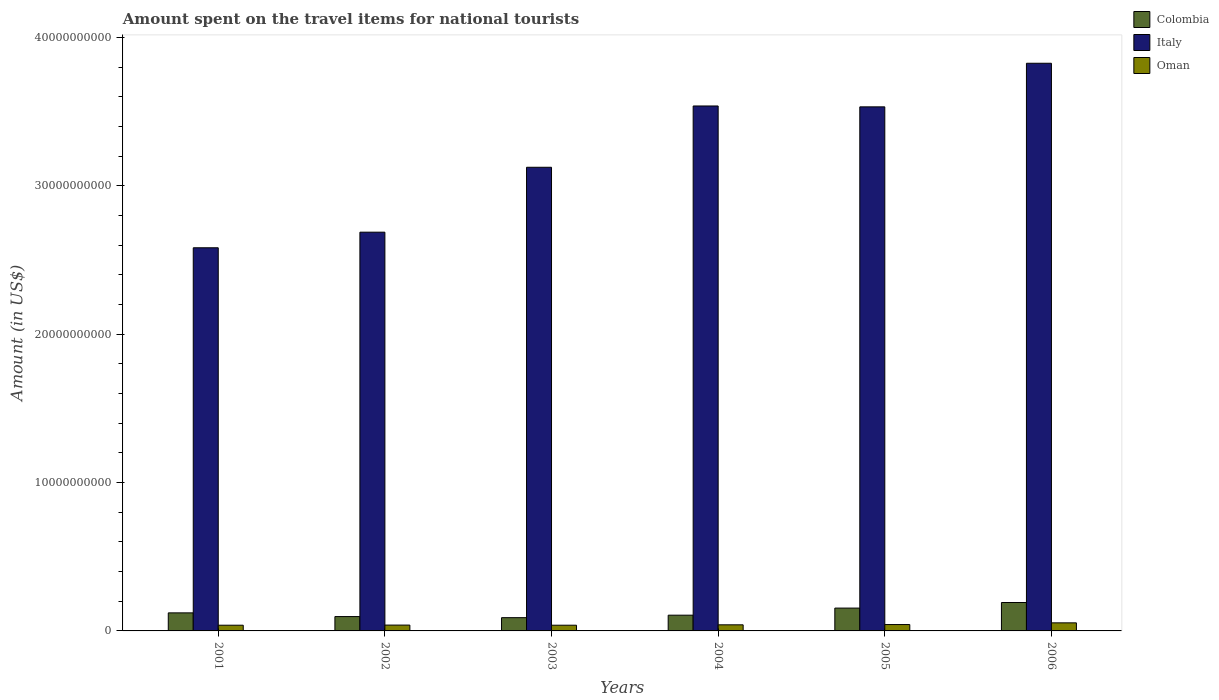Are the number of bars per tick equal to the number of legend labels?
Provide a succinct answer. Yes. How many bars are there on the 5th tick from the right?
Ensure brevity in your answer.  3. In how many cases, is the number of bars for a given year not equal to the number of legend labels?
Offer a very short reply. 0. What is the amount spent on the travel items for national tourists in Italy in 2002?
Provide a short and direct response. 2.69e+1. Across all years, what is the maximum amount spent on the travel items for national tourists in Italy?
Ensure brevity in your answer.  3.83e+1. Across all years, what is the minimum amount spent on the travel items for national tourists in Oman?
Your response must be concise. 3.85e+08. In which year was the amount spent on the travel items for national tourists in Colombia minimum?
Ensure brevity in your answer.  2003. What is the total amount spent on the travel items for national tourists in Oman in the graph?
Give a very brief answer. 2.55e+09. What is the difference between the amount spent on the travel items for national tourists in Italy in 2001 and that in 2006?
Your answer should be very brief. -1.24e+1. What is the difference between the amount spent on the travel items for national tourists in Italy in 2005 and the amount spent on the travel items for national tourists in Oman in 2003?
Keep it short and to the point. 3.49e+1. What is the average amount spent on the travel items for national tourists in Italy per year?
Keep it short and to the point. 3.21e+1. In the year 2003, what is the difference between the amount spent on the travel items for national tourists in Italy and amount spent on the travel items for national tourists in Oman?
Keep it short and to the point. 3.09e+1. What is the ratio of the amount spent on the travel items for national tourists in Italy in 2002 to that in 2005?
Ensure brevity in your answer.  0.76. Is the amount spent on the travel items for national tourists in Italy in 2001 less than that in 2005?
Offer a very short reply. Yes. What is the difference between the highest and the second highest amount spent on the travel items for national tourists in Italy?
Keep it short and to the point. 2.88e+09. What is the difference between the highest and the lowest amount spent on the travel items for national tourists in Colombia?
Make the answer very short. 1.02e+09. In how many years, is the amount spent on the travel items for national tourists in Colombia greater than the average amount spent on the travel items for national tourists in Colombia taken over all years?
Keep it short and to the point. 2. What does the 3rd bar from the left in 2005 represents?
Give a very brief answer. Oman. What does the 3rd bar from the right in 2006 represents?
Provide a succinct answer. Colombia. How many bars are there?
Provide a succinct answer. 18. Are all the bars in the graph horizontal?
Make the answer very short. No. What is the difference between two consecutive major ticks on the Y-axis?
Make the answer very short. 1.00e+1. Are the values on the major ticks of Y-axis written in scientific E-notation?
Keep it short and to the point. No. How many legend labels are there?
Offer a very short reply. 3. How are the legend labels stacked?
Your answer should be compact. Vertical. What is the title of the graph?
Offer a very short reply. Amount spent on the travel items for national tourists. What is the Amount (in US$) in Colombia in 2001?
Your answer should be compact. 1.22e+09. What is the Amount (in US$) of Italy in 2001?
Offer a terse response. 2.58e+1. What is the Amount (in US$) of Oman in 2001?
Provide a succinct answer. 3.85e+08. What is the Amount (in US$) in Colombia in 2002?
Keep it short and to the point. 9.67e+08. What is the Amount (in US$) of Italy in 2002?
Keep it short and to the point. 2.69e+1. What is the Amount (in US$) of Oman in 2002?
Offer a terse response. 3.93e+08. What is the Amount (in US$) in Colombia in 2003?
Your answer should be compact. 8.93e+08. What is the Amount (in US$) in Italy in 2003?
Offer a terse response. 3.12e+1. What is the Amount (in US$) in Oman in 2003?
Provide a short and direct response. 3.85e+08. What is the Amount (in US$) in Colombia in 2004?
Your answer should be very brief. 1.06e+09. What is the Amount (in US$) in Italy in 2004?
Give a very brief answer. 3.54e+1. What is the Amount (in US$) in Oman in 2004?
Ensure brevity in your answer.  4.11e+08. What is the Amount (in US$) in Colombia in 2005?
Offer a terse response. 1.54e+09. What is the Amount (in US$) of Italy in 2005?
Offer a terse response. 3.53e+1. What is the Amount (in US$) in Oman in 2005?
Keep it short and to the point. 4.29e+08. What is the Amount (in US$) in Colombia in 2006?
Your response must be concise. 1.92e+09. What is the Amount (in US$) in Italy in 2006?
Give a very brief answer. 3.83e+1. What is the Amount (in US$) in Oman in 2006?
Your answer should be compact. 5.44e+08. Across all years, what is the maximum Amount (in US$) in Colombia?
Ensure brevity in your answer.  1.92e+09. Across all years, what is the maximum Amount (in US$) of Italy?
Your answer should be compact. 3.83e+1. Across all years, what is the maximum Amount (in US$) in Oman?
Ensure brevity in your answer.  5.44e+08. Across all years, what is the minimum Amount (in US$) in Colombia?
Your answer should be compact. 8.93e+08. Across all years, what is the minimum Amount (in US$) of Italy?
Make the answer very short. 2.58e+1. Across all years, what is the minimum Amount (in US$) in Oman?
Ensure brevity in your answer.  3.85e+08. What is the total Amount (in US$) of Colombia in the graph?
Your response must be concise. 7.59e+09. What is the total Amount (in US$) in Italy in the graph?
Offer a terse response. 1.93e+11. What is the total Amount (in US$) of Oman in the graph?
Your response must be concise. 2.55e+09. What is the difference between the Amount (in US$) of Colombia in 2001 and that in 2002?
Give a very brief answer. 2.50e+08. What is the difference between the Amount (in US$) in Italy in 2001 and that in 2002?
Provide a succinct answer. -1.05e+09. What is the difference between the Amount (in US$) in Oman in 2001 and that in 2002?
Provide a succinct answer. -8.00e+06. What is the difference between the Amount (in US$) of Colombia in 2001 and that in 2003?
Give a very brief answer. 3.24e+08. What is the difference between the Amount (in US$) in Italy in 2001 and that in 2003?
Your answer should be very brief. -5.42e+09. What is the difference between the Amount (in US$) in Colombia in 2001 and that in 2004?
Make the answer very short. 1.56e+08. What is the difference between the Amount (in US$) in Italy in 2001 and that in 2004?
Your response must be concise. -9.56e+09. What is the difference between the Amount (in US$) in Oman in 2001 and that in 2004?
Offer a very short reply. -2.60e+07. What is the difference between the Amount (in US$) in Colombia in 2001 and that in 2005?
Keep it short and to the point. -3.22e+08. What is the difference between the Amount (in US$) in Italy in 2001 and that in 2005?
Offer a terse response. -9.50e+09. What is the difference between the Amount (in US$) in Oman in 2001 and that in 2005?
Make the answer very short. -4.40e+07. What is the difference between the Amount (in US$) in Colombia in 2001 and that in 2006?
Your response must be concise. -6.98e+08. What is the difference between the Amount (in US$) of Italy in 2001 and that in 2006?
Your response must be concise. -1.24e+1. What is the difference between the Amount (in US$) in Oman in 2001 and that in 2006?
Your response must be concise. -1.59e+08. What is the difference between the Amount (in US$) of Colombia in 2002 and that in 2003?
Provide a succinct answer. 7.40e+07. What is the difference between the Amount (in US$) in Italy in 2002 and that in 2003?
Offer a very short reply. -4.37e+09. What is the difference between the Amount (in US$) in Colombia in 2002 and that in 2004?
Your answer should be compact. -9.40e+07. What is the difference between the Amount (in US$) of Italy in 2002 and that in 2004?
Give a very brief answer. -8.50e+09. What is the difference between the Amount (in US$) of Oman in 2002 and that in 2004?
Make the answer very short. -1.80e+07. What is the difference between the Amount (in US$) in Colombia in 2002 and that in 2005?
Ensure brevity in your answer.  -5.72e+08. What is the difference between the Amount (in US$) in Italy in 2002 and that in 2005?
Your response must be concise. -8.45e+09. What is the difference between the Amount (in US$) of Oman in 2002 and that in 2005?
Your answer should be very brief. -3.60e+07. What is the difference between the Amount (in US$) of Colombia in 2002 and that in 2006?
Your answer should be very brief. -9.48e+08. What is the difference between the Amount (in US$) in Italy in 2002 and that in 2006?
Your answer should be very brief. -1.14e+1. What is the difference between the Amount (in US$) in Oman in 2002 and that in 2006?
Offer a terse response. -1.51e+08. What is the difference between the Amount (in US$) of Colombia in 2003 and that in 2004?
Provide a succinct answer. -1.68e+08. What is the difference between the Amount (in US$) in Italy in 2003 and that in 2004?
Provide a short and direct response. -4.13e+09. What is the difference between the Amount (in US$) of Oman in 2003 and that in 2004?
Provide a succinct answer. -2.60e+07. What is the difference between the Amount (in US$) of Colombia in 2003 and that in 2005?
Your response must be concise. -6.46e+08. What is the difference between the Amount (in US$) of Italy in 2003 and that in 2005?
Offer a terse response. -4.07e+09. What is the difference between the Amount (in US$) of Oman in 2003 and that in 2005?
Your answer should be compact. -4.40e+07. What is the difference between the Amount (in US$) in Colombia in 2003 and that in 2006?
Make the answer very short. -1.02e+09. What is the difference between the Amount (in US$) in Italy in 2003 and that in 2006?
Your response must be concise. -7.01e+09. What is the difference between the Amount (in US$) in Oman in 2003 and that in 2006?
Keep it short and to the point. -1.59e+08. What is the difference between the Amount (in US$) in Colombia in 2004 and that in 2005?
Your response must be concise. -4.78e+08. What is the difference between the Amount (in US$) of Italy in 2004 and that in 2005?
Provide a succinct answer. 5.90e+07. What is the difference between the Amount (in US$) of Oman in 2004 and that in 2005?
Provide a succinct answer. -1.80e+07. What is the difference between the Amount (in US$) of Colombia in 2004 and that in 2006?
Give a very brief answer. -8.54e+08. What is the difference between the Amount (in US$) of Italy in 2004 and that in 2006?
Offer a terse response. -2.88e+09. What is the difference between the Amount (in US$) in Oman in 2004 and that in 2006?
Your answer should be compact. -1.33e+08. What is the difference between the Amount (in US$) in Colombia in 2005 and that in 2006?
Your response must be concise. -3.76e+08. What is the difference between the Amount (in US$) of Italy in 2005 and that in 2006?
Ensure brevity in your answer.  -2.94e+09. What is the difference between the Amount (in US$) in Oman in 2005 and that in 2006?
Keep it short and to the point. -1.15e+08. What is the difference between the Amount (in US$) of Colombia in 2001 and the Amount (in US$) of Italy in 2002?
Keep it short and to the point. -2.57e+1. What is the difference between the Amount (in US$) of Colombia in 2001 and the Amount (in US$) of Oman in 2002?
Give a very brief answer. 8.24e+08. What is the difference between the Amount (in US$) in Italy in 2001 and the Amount (in US$) in Oman in 2002?
Provide a succinct answer. 2.54e+1. What is the difference between the Amount (in US$) in Colombia in 2001 and the Amount (in US$) in Italy in 2003?
Provide a succinct answer. -3.00e+1. What is the difference between the Amount (in US$) in Colombia in 2001 and the Amount (in US$) in Oman in 2003?
Your response must be concise. 8.32e+08. What is the difference between the Amount (in US$) of Italy in 2001 and the Amount (in US$) of Oman in 2003?
Your response must be concise. 2.54e+1. What is the difference between the Amount (in US$) of Colombia in 2001 and the Amount (in US$) of Italy in 2004?
Provide a succinct answer. -3.42e+1. What is the difference between the Amount (in US$) of Colombia in 2001 and the Amount (in US$) of Oman in 2004?
Provide a short and direct response. 8.06e+08. What is the difference between the Amount (in US$) of Italy in 2001 and the Amount (in US$) of Oman in 2004?
Provide a short and direct response. 2.54e+1. What is the difference between the Amount (in US$) in Colombia in 2001 and the Amount (in US$) in Italy in 2005?
Provide a short and direct response. -3.41e+1. What is the difference between the Amount (in US$) in Colombia in 2001 and the Amount (in US$) in Oman in 2005?
Offer a terse response. 7.88e+08. What is the difference between the Amount (in US$) in Italy in 2001 and the Amount (in US$) in Oman in 2005?
Make the answer very short. 2.54e+1. What is the difference between the Amount (in US$) in Colombia in 2001 and the Amount (in US$) in Italy in 2006?
Offer a very short reply. -3.70e+1. What is the difference between the Amount (in US$) of Colombia in 2001 and the Amount (in US$) of Oman in 2006?
Provide a short and direct response. 6.73e+08. What is the difference between the Amount (in US$) of Italy in 2001 and the Amount (in US$) of Oman in 2006?
Your answer should be very brief. 2.53e+1. What is the difference between the Amount (in US$) of Colombia in 2002 and the Amount (in US$) of Italy in 2003?
Provide a short and direct response. -3.03e+1. What is the difference between the Amount (in US$) of Colombia in 2002 and the Amount (in US$) of Oman in 2003?
Your answer should be compact. 5.82e+08. What is the difference between the Amount (in US$) in Italy in 2002 and the Amount (in US$) in Oman in 2003?
Give a very brief answer. 2.65e+1. What is the difference between the Amount (in US$) of Colombia in 2002 and the Amount (in US$) of Italy in 2004?
Your answer should be compact. -3.44e+1. What is the difference between the Amount (in US$) in Colombia in 2002 and the Amount (in US$) in Oman in 2004?
Ensure brevity in your answer.  5.56e+08. What is the difference between the Amount (in US$) of Italy in 2002 and the Amount (in US$) of Oman in 2004?
Give a very brief answer. 2.65e+1. What is the difference between the Amount (in US$) in Colombia in 2002 and the Amount (in US$) in Italy in 2005?
Keep it short and to the point. -3.44e+1. What is the difference between the Amount (in US$) of Colombia in 2002 and the Amount (in US$) of Oman in 2005?
Your answer should be very brief. 5.38e+08. What is the difference between the Amount (in US$) of Italy in 2002 and the Amount (in US$) of Oman in 2005?
Offer a very short reply. 2.64e+1. What is the difference between the Amount (in US$) in Colombia in 2002 and the Amount (in US$) in Italy in 2006?
Provide a succinct answer. -3.73e+1. What is the difference between the Amount (in US$) of Colombia in 2002 and the Amount (in US$) of Oman in 2006?
Offer a very short reply. 4.23e+08. What is the difference between the Amount (in US$) of Italy in 2002 and the Amount (in US$) of Oman in 2006?
Offer a very short reply. 2.63e+1. What is the difference between the Amount (in US$) in Colombia in 2003 and the Amount (in US$) in Italy in 2004?
Offer a very short reply. -3.45e+1. What is the difference between the Amount (in US$) in Colombia in 2003 and the Amount (in US$) in Oman in 2004?
Your answer should be very brief. 4.82e+08. What is the difference between the Amount (in US$) of Italy in 2003 and the Amount (in US$) of Oman in 2004?
Your response must be concise. 3.08e+1. What is the difference between the Amount (in US$) of Colombia in 2003 and the Amount (in US$) of Italy in 2005?
Your answer should be compact. -3.44e+1. What is the difference between the Amount (in US$) of Colombia in 2003 and the Amount (in US$) of Oman in 2005?
Make the answer very short. 4.64e+08. What is the difference between the Amount (in US$) of Italy in 2003 and the Amount (in US$) of Oman in 2005?
Offer a terse response. 3.08e+1. What is the difference between the Amount (in US$) in Colombia in 2003 and the Amount (in US$) in Italy in 2006?
Give a very brief answer. -3.74e+1. What is the difference between the Amount (in US$) of Colombia in 2003 and the Amount (in US$) of Oman in 2006?
Offer a very short reply. 3.49e+08. What is the difference between the Amount (in US$) in Italy in 2003 and the Amount (in US$) in Oman in 2006?
Make the answer very short. 3.07e+1. What is the difference between the Amount (in US$) of Colombia in 2004 and the Amount (in US$) of Italy in 2005?
Your answer should be very brief. -3.43e+1. What is the difference between the Amount (in US$) in Colombia in 2004 and the Amount (in US$) in Oman in 2005?
Give a very brief answer. 6.32e+08. What is the difference between the Amount (in US$) in Italy in 2004 and the Amount (in US$) in Oman in 2005?
Offer a very short reply. 3.49e+1. What is the difference between the Amount (in US$) of Colombia in 2004 and the Amount (in US$) of Italy in 2006?
Keep it short and to the point. -3.72e+1. What is the difference between the Amount (in US$) of Colombia in 2004 and the Amount (in US$) of Oman in 2006?
Ensure brevity in your answer.  5.17e+08. What is the difference between the Amount (in US$) in Italy in 2004 and the Amount (in US$) in Oman in 2006?
Provide a succinct answer. 3.48e+1. What is the difference between the Amount (in US$) of Colombia in 2005 and the Amount (in US$) of Italy in 2006?
Your answer should be compact. -3.67e+1. What is the difference between the Amount (in US$) in Colombia in 2005 and the Amount (in US$) in Oman in 2006?
Provide a succinct answer. 9.95e+08. What is the difference between the Amount (in US$) in Italy in 2005 and the Amount (in US$) in Oman in 2006?
Give a very brief answer. 3.48e+1. What is the average Amount (in US$) in Colombia per year?
Your response must be concise. 1.27e+09. What is the average Amount (in US$) of Italy per year?
Make the answer very short. 3.21e+1. What is the average Amount (in US$) of Oman per year?
Give a very brief answer. 4.24e+08. In the year 2001, what is the difference between the Amount (in US$) of Colombia and Amount (in US$) of Italy?
Your answer should be very brief. -2.46e+1. In the year 2001, what is the difference between the Amount (in US$) in Colombia and Amount (in US$) in Oman?
Keep it short and to the point. 8.32e+08. In the year 2001, what is the difference between the Amount (in US$) in Italy and Amount (in US$) in Oman?
Offer a terse response. 2.54e+1. In the year 2002, what is the difference between the Amount (in US$) of Colombia and Amount (in US$) of Italy?
Ensure brevity in your answer.  -2.59e+1. In the year 2002, what is the difference between the Amount (in US$) in Colombia and Amount (in US$) in Oman?
Provide a short and direct response. 5.74e+08. In the year 2002, what is the difference between the Amount (in US$) in Italy and Amount (in US$) in Oman?
Your response must be concise. 2.65e+1. In the year 2003, what is the difference between the Amount (in US$) in Colombia and Amount (in US$) in Italy?
Provide a short and direct response. -3.04e+1. In the year 2003, what is the difference between the Amount (in US$) of Colombia and Amount (in US$) of Oman?
Give a very brief answer. 5.08e+08. In the year 2003, what is the difference between the Amount (in US$) in Italy and Amount (in US$) in Oman?
Your response must be concise. 3.09e+1. In the year 2004, what is the difference between the Amount (in US$) of Colombia and Amount (in US$) of Italy?
Keep it short and to the point. -3.43e+1. In the year 2004, what is the difference between the Amount (in US$) in Colombia and Amount (in US$) in Oman?
Offer a terse response. 6.50e+08. In the year 2004, what is the difference between the Amount (in US$) in Italy and Amount (in US$) in Oman?
Offer a terse response. 3.50e+1. In the year 2005, what is the difference between the Amount (in US$) in Colombia and Amount (in US$) in Italy?
Provide a succinct answer. -3.38e+1. In the year 2005, what is the difference between the Amount (in US$) of Colombia and Amount (in US$) of Oman?
Your answer should be very brief. 1.11e+09. In the year 2005, what is the difference between the Amount (in US$) of Italy and Amount (in US$) of Oman?
Offer a terse response. 3.49e+1. In the year 2006, what is the difference between the Amount (in US$) of Colombia and Amount (in US$) of Italy?
Ensure brevity in your answer.  -3.63e+1. In the year 2006, what is the difference between the Amount (in US$) in Colombia and Amount (in US$) in Oman?
Ensure brevity in your answer.  1.37e+09. In the year 2006, what is the difference between the Amount (in US$) in Italy and Amount (in US$) in Oman?
Your answer should be compact. 3.77e+1. What is the ratio of the Amount (in US$) in Colombia in 2001 to that in 2002?
Your answer should be very brief. 1.26. What is the ratio of the Amount (in US$) in Italy in 2001 to that in 2002?
Your response must be concise. 0.96. What is the ratio of the Amount (in US$) in Oman in 2001 to that in 2002?
Make the answer very short. 0.98. What is the ratio of the Amount (in US$) in Colombia in 2001 to that in 2003?
Your answer should be compact. 1.36. What is the ratio of the Amount (in US$) of Italy in 2001 to that in 2003?
Offer a terse response. 0.83. What is the ratio of the Amount (in US$) of Colombia in 2001 to that in 2004?
Give a very brief answer. 1.15. What is the ratio of the Amount (in US$) of Italy in 2001 to that in 2004?
Your answer should be very brief. 0.73. What is the ratio of the Amount (in US$) of Oman in 2001 to that in 2004?
Make the answer very short. 0.94. What is the ratio of the Amount (in US$) in Colombia in 2001 to that in 2005?
Your answer should be compact. 0.79. What is the ratio of the Amount (in US$) in Italy in 2001 to that in 2005?
Keep it short and to the point. 0.73. What is the ratio of the Amount (in US$) of Oman in 2001 to that in 2005?
Ensure brevity in your answer.  0.9. What is the ratio of the Amount (in US$) of Colombia in 2001 to that in 2006?
Ensure brevity in your answer.  0.64. What is the ratio of the Amount (in US$) of Italy in 2001 to that in 2006?
Make the answer very short. 0.68. What is the ratio of the Amount (in US$) of Oman in 2001 to that in 2006?
Provide a short and direct response. 0.71. What is the ratio of the Amount (in US$) of Colombia in 2002 to that in 2003?
Make the answer very short. 1.08. What is the ratio of the Amount (in US$) of Italy in 2002 to that in 2003?
Make the answer very short. 0.86. What is the ratio of the Amount (in US$) in Oman in 2002 to that in 2003?
Your answer should be compact. 1.02. What is the ratio of the Amount (in US$) of Colombia in 2002 to that in 2004?
Ensure brevity in your answer.  0.91. What is the ratio of the Amount (in US$) of Italy in 2002 to that in 2004?
Offer a terse response. 0.76. What is the ratio of the Amount (in US$) of Oman in 2002 to that in 2004?
Keep it short and to the point. 0.96. What is the ratio of the Amount (in US$) in Colombia in 2002 to that in 2005?
Ensure brevity in your answer.  0.63. What is the ratio of the Amount (in US$) in Italy in 2002 to that in 2005?
Your response must be concise. 0.76. What is the ratio of the Amount (in US$) in Oman in 2002 to that in 2005?
Give a very brief answer. 0.92. What is the ratio of the Amount (in US$) of Colombia in 2002 to that in 2006?
Make the answer very short. 0.51. What is the ratio of the Amount (in US$) in Italy in 2002 to that in 2006?
Ensure brevity in your answer.  0.7. What is the ratio of the Amount (in US$) of Oman in 2002 to that in 2006?
Your answer should be very brief. 0.72. What is the ratio of the Amount (in US$) of Colombia in 2003 to that in 2004?
Make the answer very short. 0.84. What is the ratio of the Amount (in US$) in Italy in 2003 to that in 2004?
Offer a terse response. 0.88. What is the ratio of the Amount (in US$) of Oman in 2003 to that in 2004?
Your response must be concise. 0.94. What is the ratio of the Amount (in US$) in Colombia in 2003 to that in 2005?
Offer a terse response. 0.58. What is the ratio of the Amount (in US$) in Italy in 2003 to that in 2005?
Make the answer very short. 0.88. What is the ratio of the Amount (in US$) of Oman in 2003 to that in 2005?
Your answer should be compact. 0.9. What is the ratio of the Amount (in US$) of Colombia in 2003 to that in 2006?
Offer a very short reply. 0.47. What is the ratio of the Amount (in US$) of Italy in 2003 to that in 2006?
Your answer should be very brief. 0.82. What is the ratio of the Amount (in US$) in Oman in 2003 to that in 2006?
Keep it short and to the point. 0.71. What is the ratio of the Amount (in US$) in Colombia in 2004 to that in 2005?
Make the answer very short. 0.69. What is the ratio of the Amount (in US$) of Oman in 2004 to that in 2005?
Your response must be concise. 0.96. What is the ratio of the Amount (in US$) of Colombia in 2004 to that in 2006?
Offer a very short reply. 0.55. What is the ratio of the Amount (in US$) in Italy in 2004 to that in 2006?
Make the answer very short. 0.92. What is the ratio of the Amount (in US$) of Oman in 2004 to that in 2006?
Keep it short and to the point. 0.76. What is the ratio of the Amount (in US$) in Colombia in 2005 to that in 2006?
Provide a succinct answer. 0.8. What is the ratio of the Amount (in US$) in Italy in 2005 to that in 2006?
Your answer should be very brief. 0.92. What is the ratio of the Amount (in US$) of Oman in 2005 to that in 2006?
Your answer should be very brief. 0.79. What is the difference between the highest and the second highest Amount (in US$) in Colombia?
Your response must be concise. 3.76e+08. What is the difference between the highest and the second highest Amount (in US$) of Italy?
Offer a terse response. 2.88e+09. What is the difference between the highest and the second highest Amount (in US$) in Oman?
Provide a succinct answer. 1.15e+08. What is the difference between the highest and the lowest Amount (in US$) of Colombia?
Your answer should be very brief. 1.02e+09. What is the difference between the highest and the lowest Amount (in US$) of Italy?
Provide a short and direct response. 1.24e+1. What is the difference between the highest and the lowest Amount (in US$) in Oman?
Provide a short and direct response. 1.59e+08. 